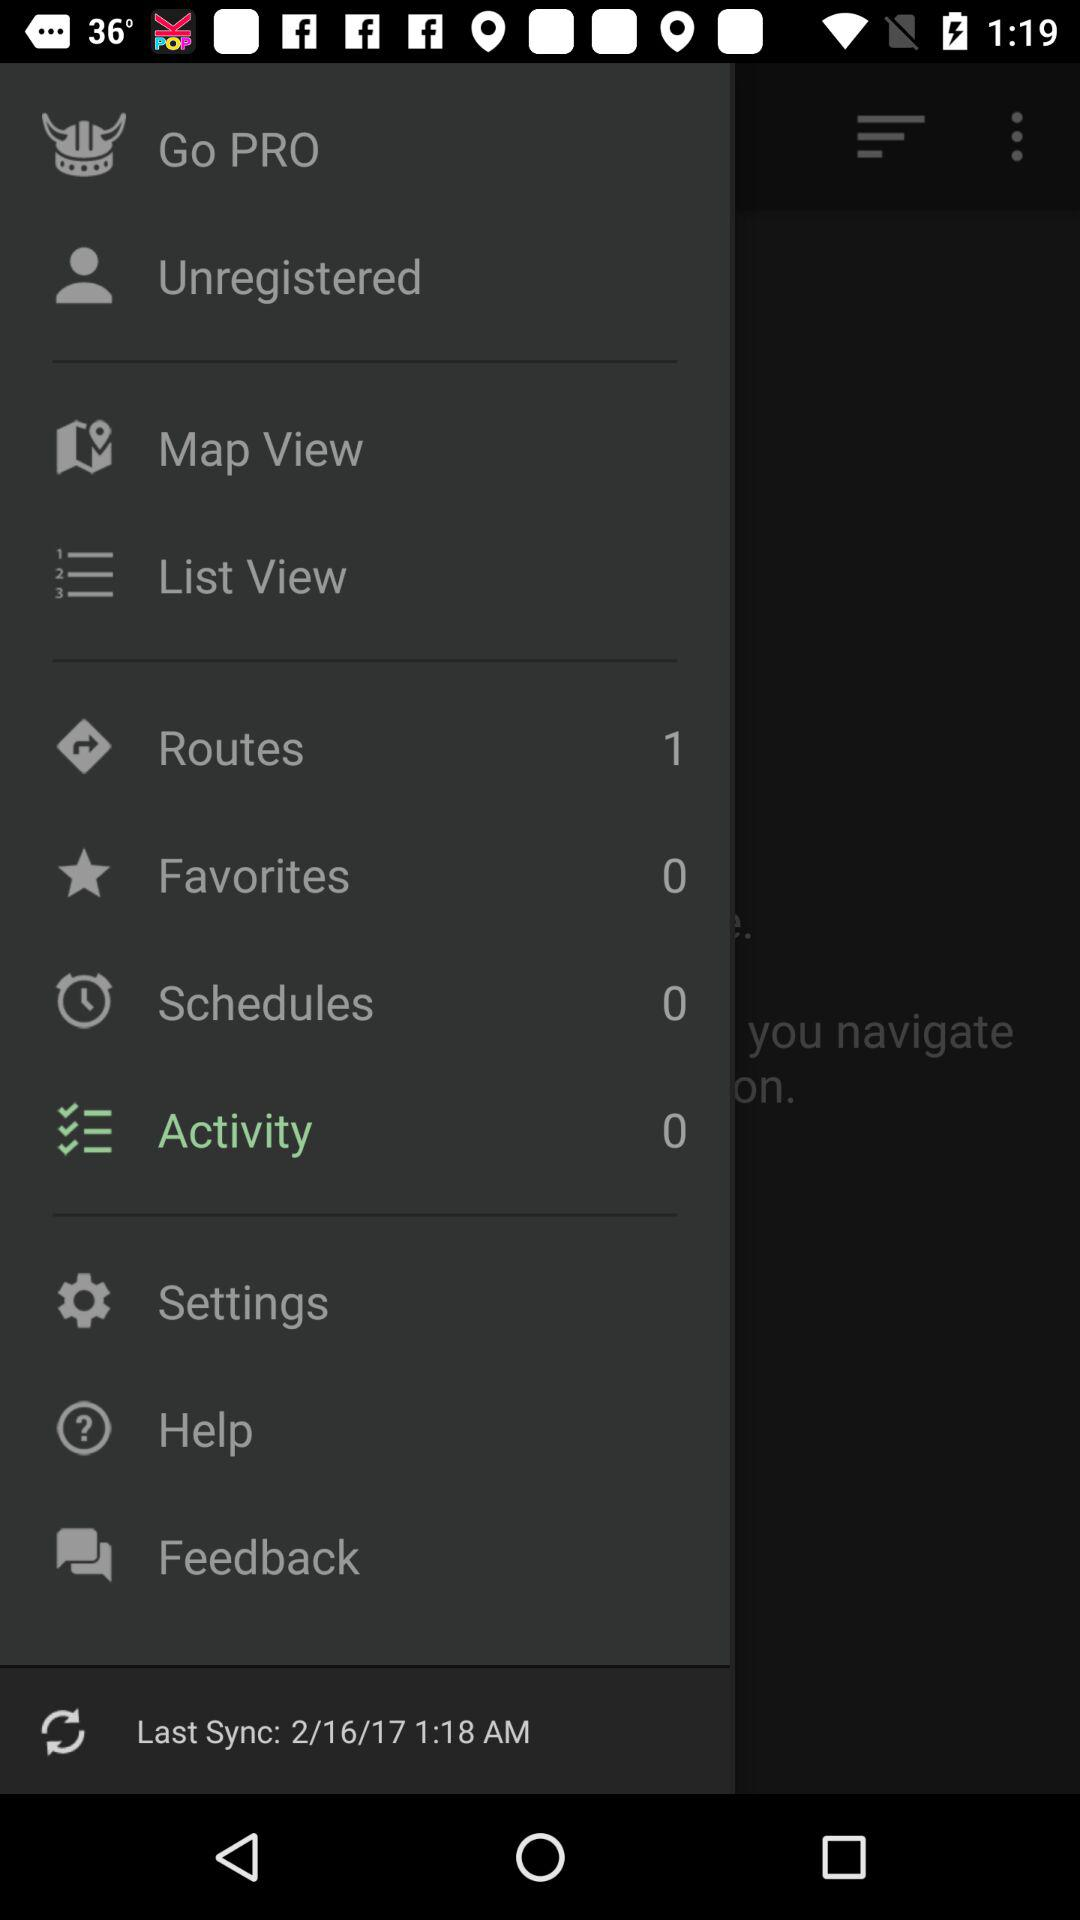How many "Favorites" are there in total? There are 0 "Favorites" in total. 